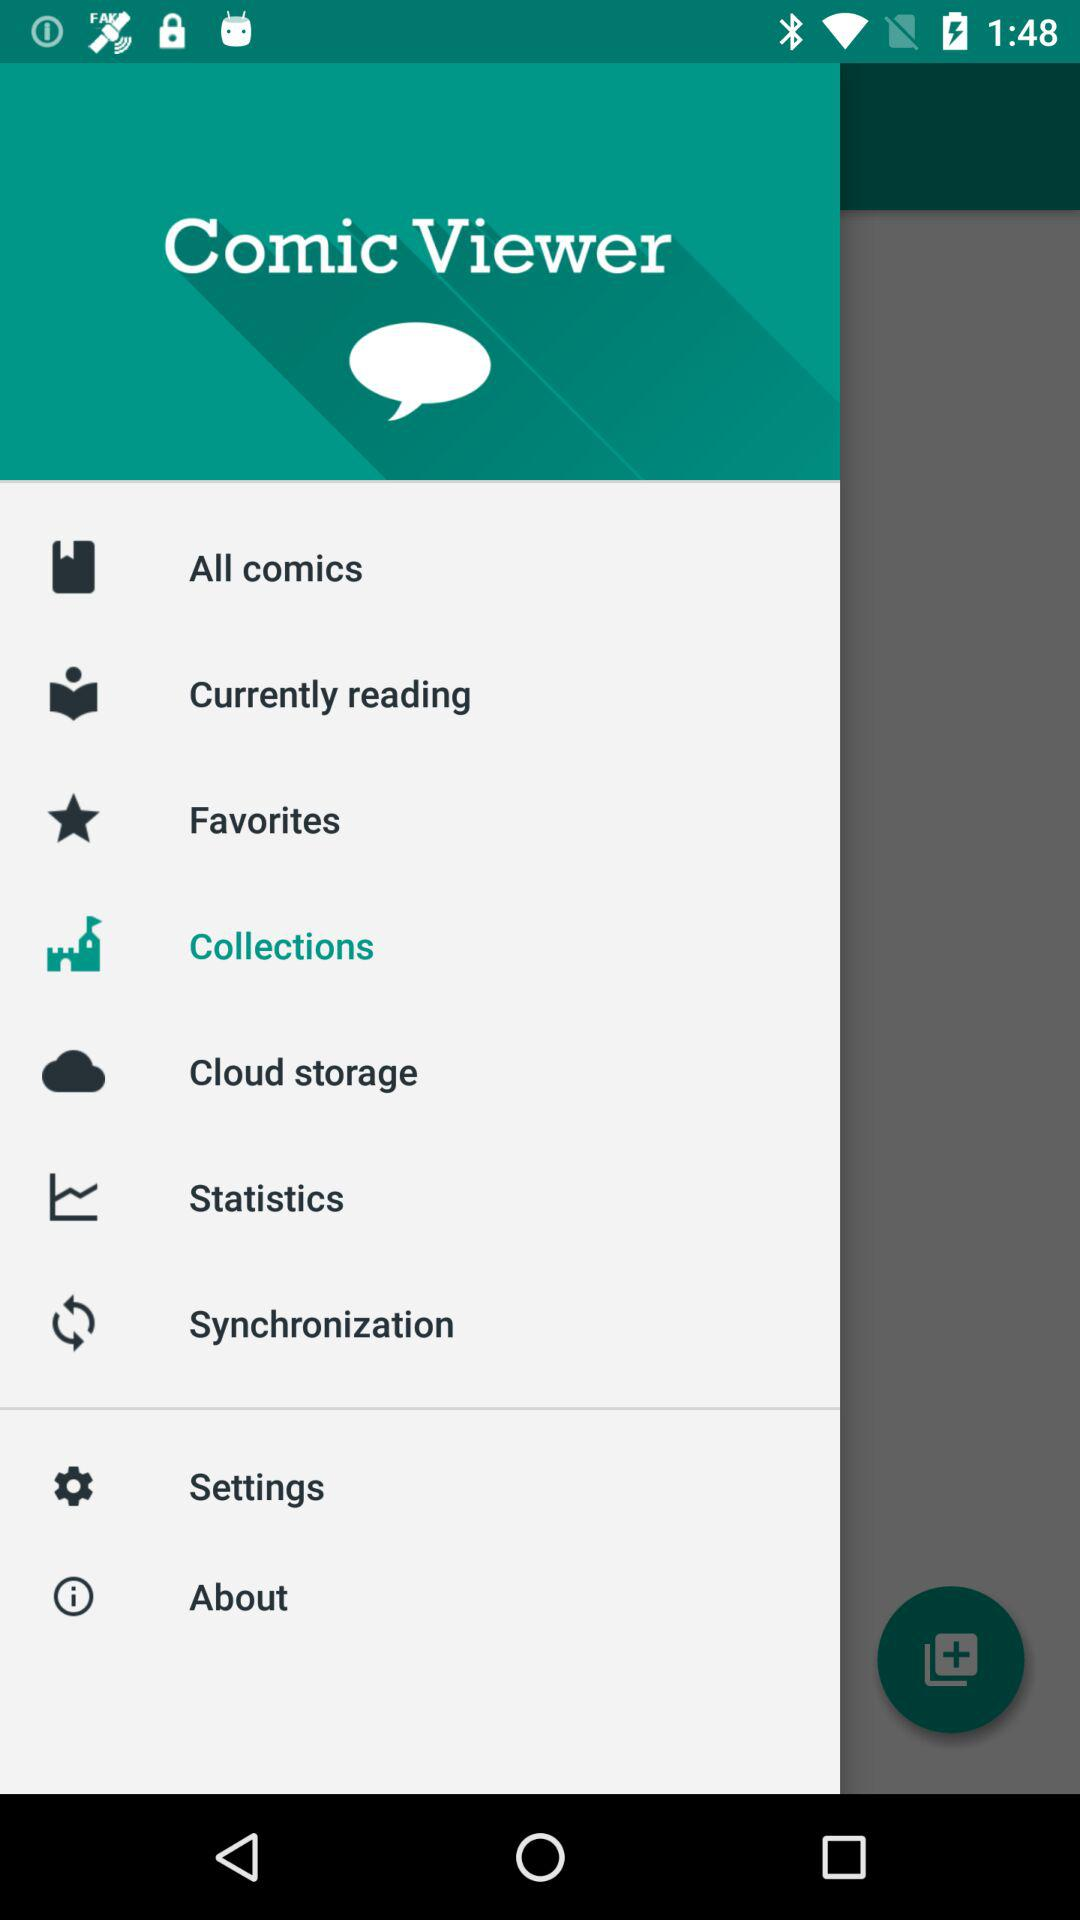What is the application name? The application name is "Comic Viewer". 